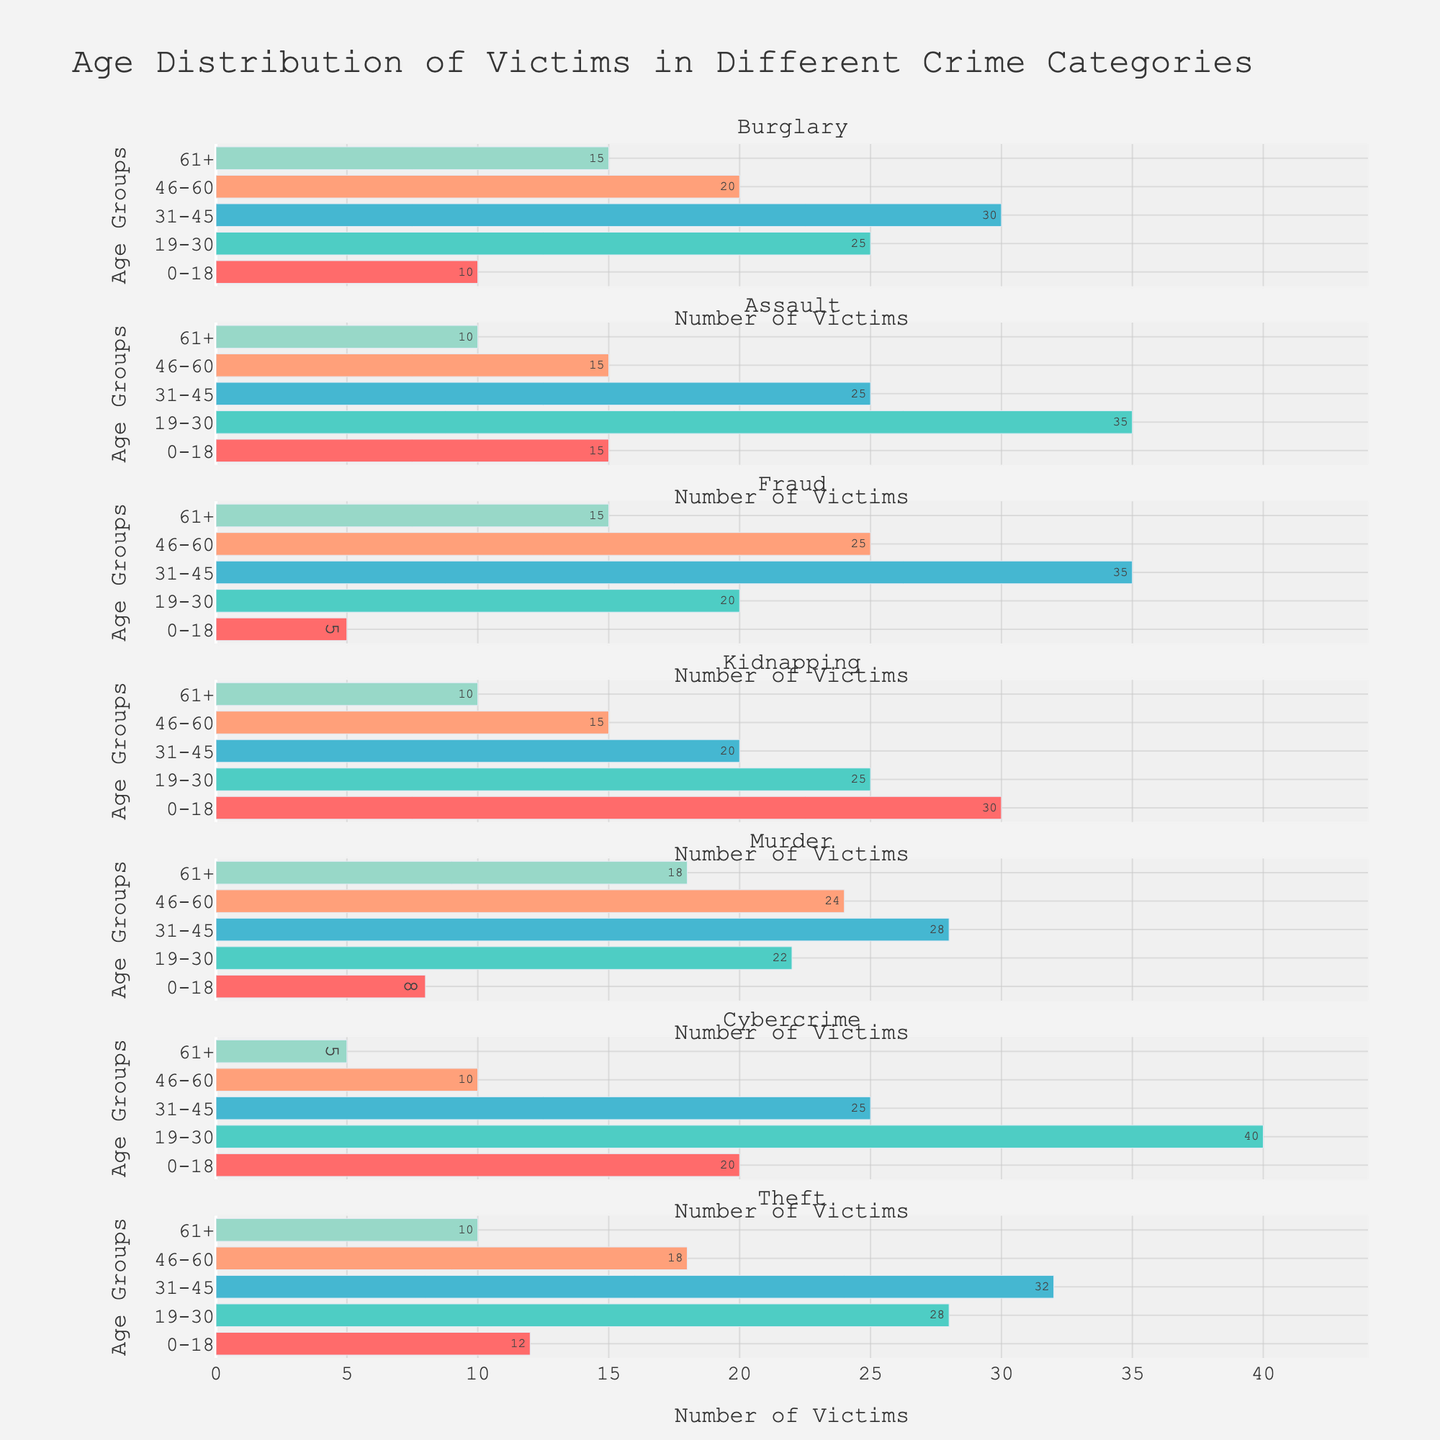What is the title of the figure? The title of the figure is located at the top and usually summarizes the overall content or purpose of the visualization. Here, it is "Age Distribution of Victims in Different Crime Categories".
Answer: Age Distribution of Victims in Different Crime Categories Which crime category has the highest number of victims aged 19-30? To find this, locate the subplot corresponding to each crime category and identify the bar representing the age group 19-30. The highest value in this age group can be seen in the Cybercrime category with 40 victims.
Answer: Cybercrime How many more victims aged 0-18 does Kidnapping have compared to Fraud? Locate the subplots for Kidnapping and Fraud, and check the length of the bars for the age group 0-18. Kidnapping has 30 victims, while Fraud has 5, resulting in a difference of 30 - 5 = 25 victims.
Answer: 25 Which age group has the least number of victims in Murder? In the subplot for Murder, identify the bar with the smallest length. The least number of victims falls in the age group '61+', which constitutes 18 victims.
Answer: 61+ Are there more victims aged 31-45 in Assault or in Theft? Compare the lengths of the bars representing the age group 31-45 in the Assault and Theft subplots. Assault has 25 victims, whereas Theft has 32, so there are more victims in the Theft category.
Answer: Theft What is the range of the x-axis for the number of victims? The x-axis range is visible at the bottom of the plot, extending from the minimum value to a little beyond the maximum value in the data. Here, it ranges from 0 to approximately 44.
Answer: 0 to 44 Which crime category shows the smallest discrepancy in the number of victims across all age groups? To determine this, observe the subplots and look for the crime category with the most uniform distribution of bar lengths across the age groups. Fraud has relatively uniform bar lengths across all age groups compared to other categories.
Answer: Fraud Summarize the total number of victims aged 46-60 across all crime categories. For each subplot, find the bar representing the age group 46-60 and sum their values: Burglary (20) + Assault (15) + Fraud (25) + Kidnapping (15) + Murder (24) + Cybercrime (10) + Theft (18). The total is 127 victims.
Answer: 127 Which age group consistently shows an increase in victim count across all the crime categories, excluding any anomalies? To answer, we must observe the trend across all subplots for each age group. Victim counts in the age group 19-30 generally show an increase or remain high across categories, making it consistent in comparison to other age groups.
Answer: 19-30 